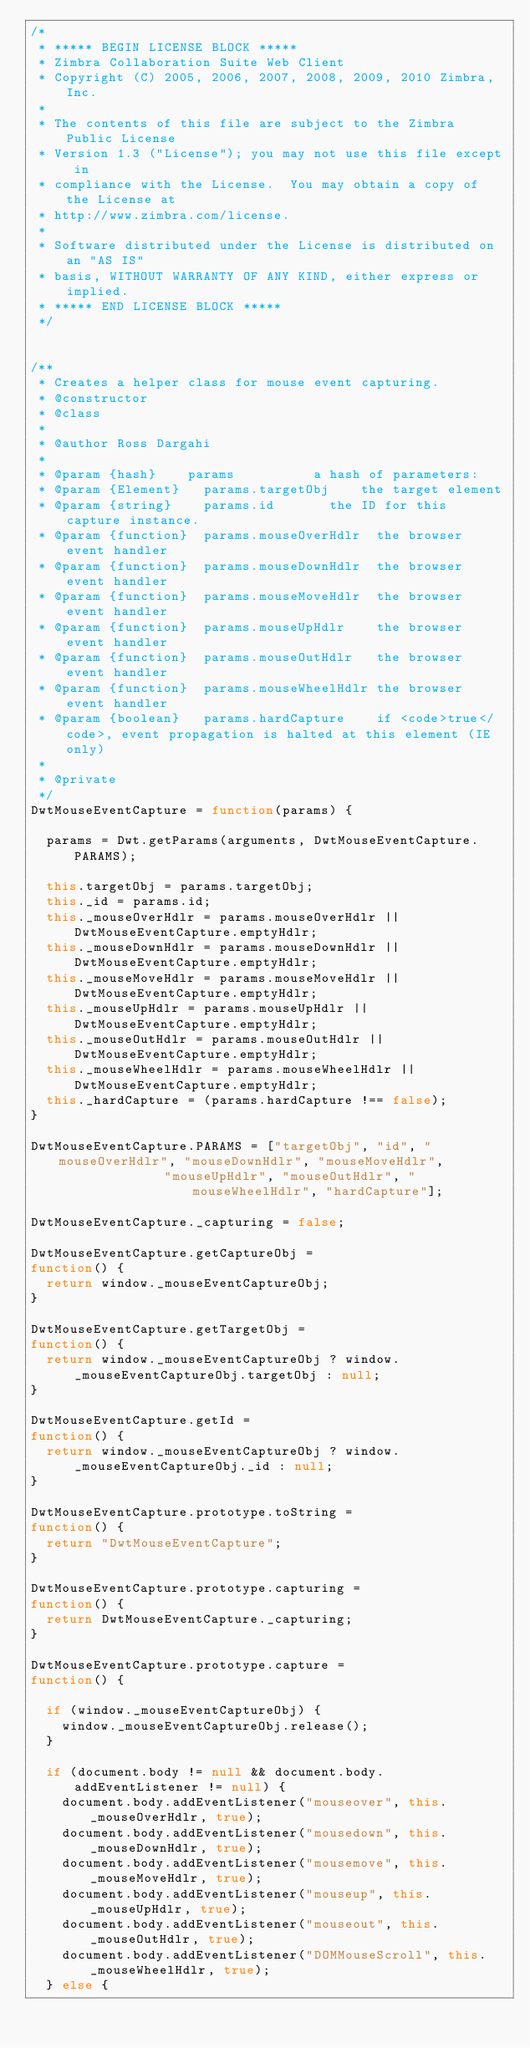Convert code to text. <code><loc_0><loc_0><loc_500><loc_500><_JavaScript_>/*
 * ***** BEGIN LICENSE BLOCK *****
 * Zimbra Collaboration Suite Web Client
 * Copyright (C) 2005, 2006, 2007, 2008, 2009, 2010 Zimbra, Inc.
 * 
 * The contents of this file are subject to the Zimbra Public License
 * Version 1.3 ("License"); you may not use this file except in
 * compliance with the License.  You may obtain a copy of the License at
 * http://www.zimbra.com/license.
 * 
 * Software distributed under the License is distributed on an "AS IS"
 * basis, WITHOUT WARRANTY OF ANY KIND, either express or implied.
 * ***** END LICENSE BLOCK *****
 */


/**
 * Creates a helper class for mouse event capturing.
 * @constructor
 * @class
 *
 * @author Ross Dargahi
 *
 * @param {hash}		params					a hash of parameters:
 * @param {Element}		params.targetObj		the target element
 * @param {string}		params.id				the ID for this capture instance.
 * @param {function}	params.mouseOverHdlr	the browser event handler
 * @param {function}	params.mouseDownHdlr	the browser event handler
 * @param {function}	params.mouseMoveHdlr	the browser event handler
 * @param {function}	params.mouseUpHdlr		the browser event handler
 * @param {function}	params.mouseOutHdlr		the browser event handler
 * @param {function}	params.mouseWheelHdlr	the browser event handler
 * @param {boolean}		params.hardCapture		if <code>true</code>, event propagation is halted at this element (IE only)
 *
 * @private
 */
DwtMouseEventCapture = function(params) {

	params = Dwt.getParams(arguments, DwtMouseEventCapture.PARAMS);

	this.targetObj = params.targetObj;
	this._id = params.id;
	this._mouseOverHdlr = params.mouseOverHdlr || DwtMouseEventCapture.emptyHdlr;
	this._mouseDownHdlr = params.mouseDownHdlr || DwtMouseEventCapture.emptyHdlr;
	this._mouseMoveHdlr = params.mouseMoveHdlr || DwtMouseEventCapture.emptyHdlr;
	this._mouseUpHdlr = params.mouseUpHdlr || DwtMouseEventCapture.emptyHdlr;
	this._mouseOutHdlr = params.mouseOutHdlr || DwtMouseEventCapture.emptyHdlr;
	this._mouseWheelHdlr = params.mouseWheelHdlr || DwtMouseEventCapture.emptyHdlr;
	this._hardCapture = (params.hardCapture !== false);
}

DwtMouseEventCapture.PARAMS = ["targetObj", "id", "mouseOverHdlr", "mouseDownHdlr", "mouseMoveHdlr",
							   "mouseUpHdlr", "mouseOutHdlr", "mouseWheelHdlr", "hardCapture"];

DwtMouseEventCapture._capturing = false;

DwtMouseEventCapture.getCaptureObj =
function() {
	return window._mouseEventCaptureObj;
}

DwtMouseEventCapture.getTargetObj =
function() {
	return window._mouseEventCaptureObj ? window._mouseEventCaptureObj.targetObj : null;
}

DwtMouseEventCapture.getId =
function() {
	return window._mouseEventCaptureObj ? window._mouseEventCaptureObj._id : null;
}

DwtMouseEventCapture.prototype.toString = 
function() {
	return "DwtMouseEventCapture";
}

DwtMouseEventCapture.prototype.capturing =
function() {
	return DwtMouseEventCapture._capturing;
}

DwtMouseEventCapture.prototype.capture =
function() {

	if (window._mouseEventCaptureObj) {
		window._mouseEventCaptureObj.release();
	}

	if (document.body != null && document.body.addEventListener != null) {
		document.body.addEventListener("mouseover", this._mouseOverHdlr, true);
		document.body.addEventListener("mousedown", this._mouseDownHdlr, true);
		document.body.addEventListener("mousemove", this._mouseMoveHdlr, true);
		document.body.addEventListener("mouseup", this._mouseUpHdlr, true);
		document.body.addEventListener("mouseout", this._mouseOutHdlr, true);
		document.body.addEventListener("DOMMouseScroll", this._mouseWheelHdlr, true);
	} else {</code> 